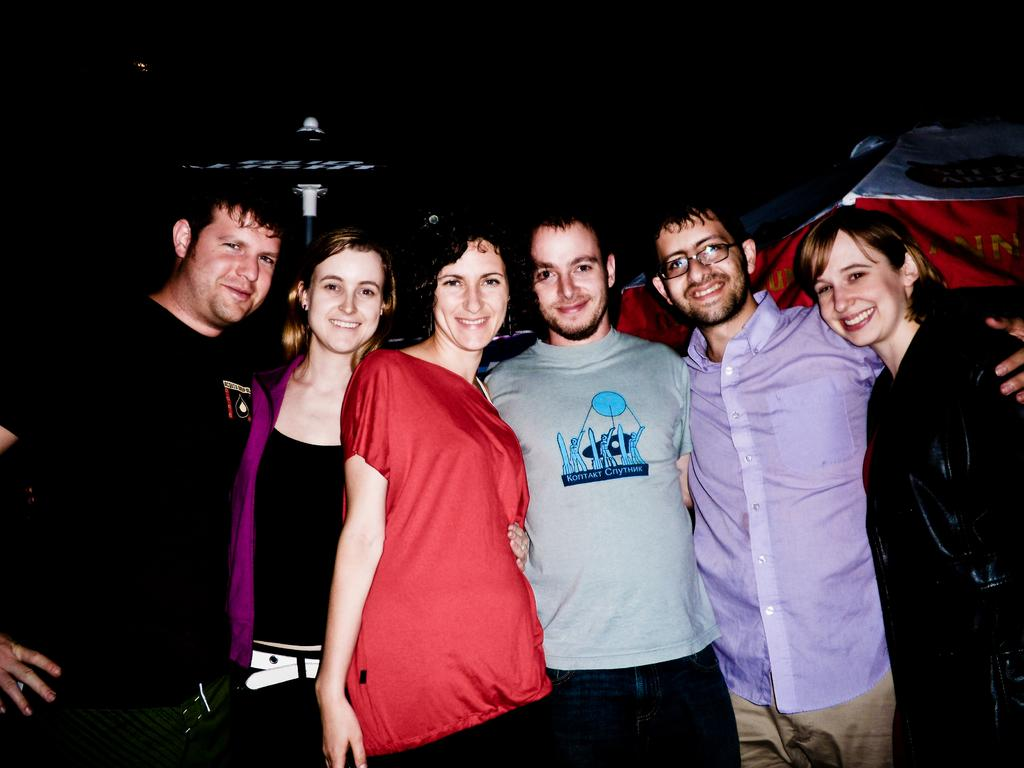What is happening in the image? There are people standing in the image. Can you describe the clothing of the people in the image? The people are wearing different color dresses. What can be seen in the background of the image? The background of the image is dark. What type of pump can be seen in the image? There is no pump present in the image. Is the moon visible in the image? The moon is not visible in the image, as the background is dark and the focus is on the people standing. Are there any cabbages in the image? There are no cabbages present in the image. 